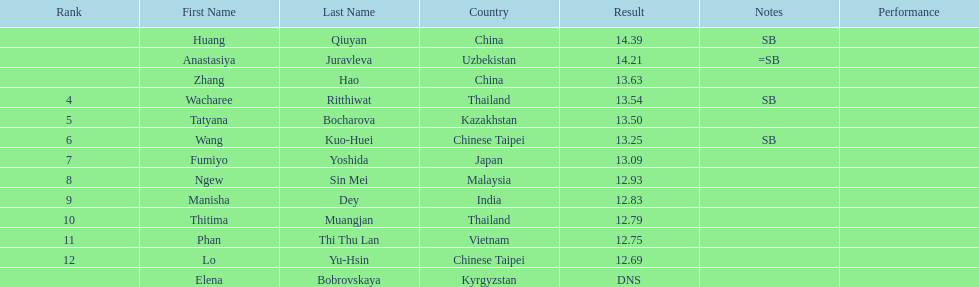How long was manisha dey's jump? 12.83. 